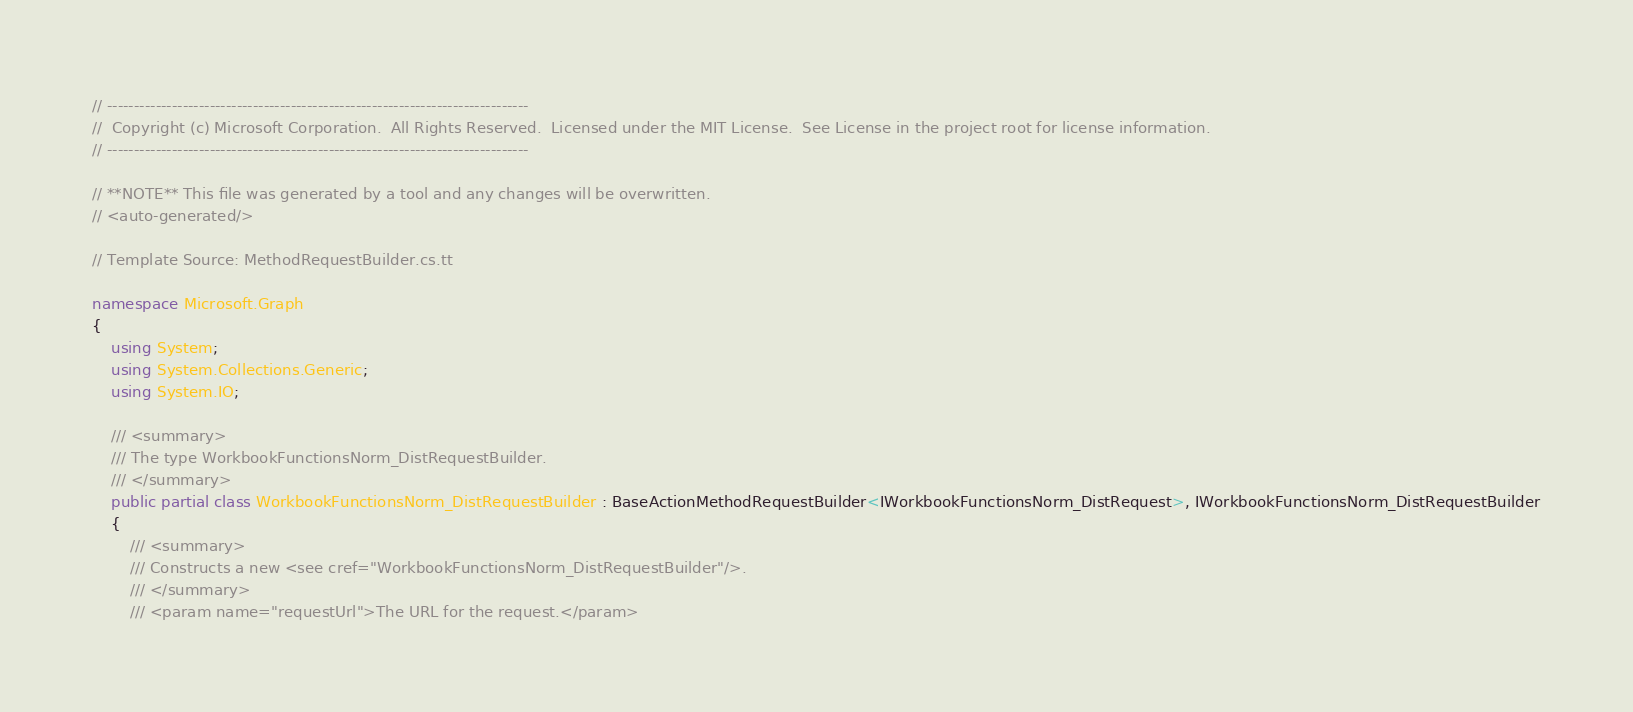Convert code to text. <code><loc_0><loc_0><loc_500><loc_500><_C#_>// ------------------------------------------------------------------------------
//  Copyright (c) Microsoft Corporation.  All Rights Reserved.  Licensed under the MIT License.  See License in the project root for license information.
// ------------------------------------------------------------------------------

// **NOTE** This file was generated by a tool and any changes will be overwritten.
// <auto-generated/>

// Template Source: MethodRequestBuilder.cs.tt

namespace Microsoft.Graph
{
    using System;
    using System.Collections.Generic;
    using System.IO;

    /// <summary>
    /// The type WorkbookFunctionsNorm_DistRequestBuilder.
    /// </summary>
    public partial class WorkbookFunctionsNorm_DistRequestBuilder : BaseActionMethodRequestBuilder<IWorkbookFunctionsNorm_DistRequest>, IWorkbookFunctionsNorm_DistRequestBuilder
    {
        /// <summary>
        /// Constructs a new <see cref="WorkbookFunctionsNorm_DistRequestBuilder"/>.
        /// </summary>
        /// <param name="requestUrl">The URL for the request.</param></code> 